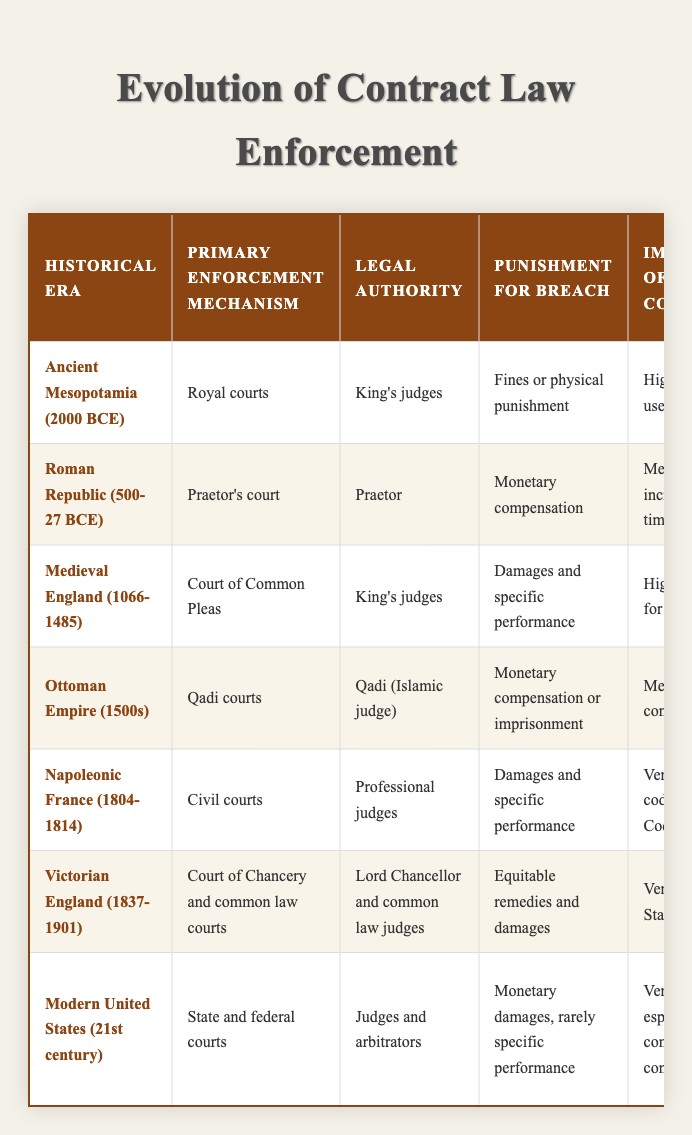What was the primary enforcement mechanism in the Ottoman Empire? The table lists the primary enforcement mechanism for the Ottoman Empire (1500s) as "Qadi courts." This information can be found in the 'Primary Enforcement Mechanism' column for the respective row.
Answer: Qadi courts Which historical era had the highest importance of written contracts? According to the table, both the Napoleonic France and Victorian England have a rating of "Very high" for the importance of written contracts. This is noted in the 'Importance of Written Contracts' column.
Answer: Napoleonic France and Victorian England How many historical eras utilized monetary compensation as punishment for breach of contract? By reviewing the 'Punishment for Breach' column, we can identify four eras that mentioned monetary compensation: Roman Republic, Ottoman Empire, Napoleonic France, and Modern United States. Therefore, the total is 4.
Answer: 4 Did the Medieval England legal system have a significant influence from religious law? The table indicates that Medieval England had a "High" influence of religious law as represented in the 'Influence of Religious Law' column. Therefore, the answer to whether it had a significant influence is yes.
Answer: Yes What is the role of witnesses in contract enforcement for the Ancient Mesopotamia era? For Ancient Mesopotamia, the table states that the role of witnesses was "Critical for verbal agreements," indicating their significant involvement in this historical period. This is found in the 'Role of Witnesses' column for that era.
Answer: Critical for verbal agreements Which two historical eras used "Damages and specific performance" as punishment for breach of contract? The table lists "Damages and specific performance" in the 'Punishment for Breach' column for both Medieval England and Napoleonic France. Thus, these two eras both utilized this type of punishment.
Answer: Medieval England and Napoleonic France Does the Modern United States system still heavily rely on written contracts? The table states that the importance of written contracts in the Modern United States is "Very high," indicating that it does indeed heavily rely on them. Therefore, the answer is yes.
Answer: Yes What can be inferred about the influence of religious law in the Roman Republic compared to the Ottoman Empire? The Roman Republic has a "Low" influence of religious law, while the Ottoman Empire has a "Very high" influence as mentioned in their respective rows under the 'Influence of Religious Law' column. This indicates a significant contrast in the role of religious law in these two eras.
Answer: Ottoman Empire had very high influence, Roman Republic had low influence 